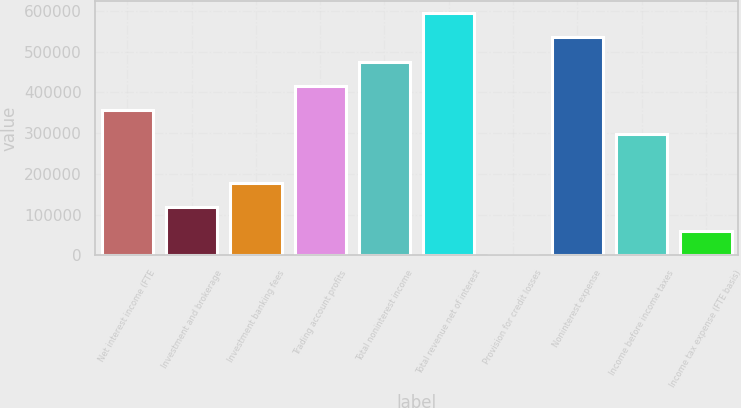<chart> <loc_0><loc_0><loc_500><loc_500><bar_chart><fcel>Net interest income (FTE<fcel>Investment and brokerage<fcel>Investment banking fees<fcel>Trading account profits<fcel>Total noninterest income<fcel>Total revenue net of interest<fcel>Provision for credit losses<fcel>Noninterest expense<fcel>Income before income taxes<fcel>Income tax expense (FTE basis)<nl><fcel>356474<fcel>118891<fcel>178286<fcel>415870<fcel>475265<fcel>594057<fcel>99<fcel>534661<fcel>297078<fcel>59494.8<nl></chart> 